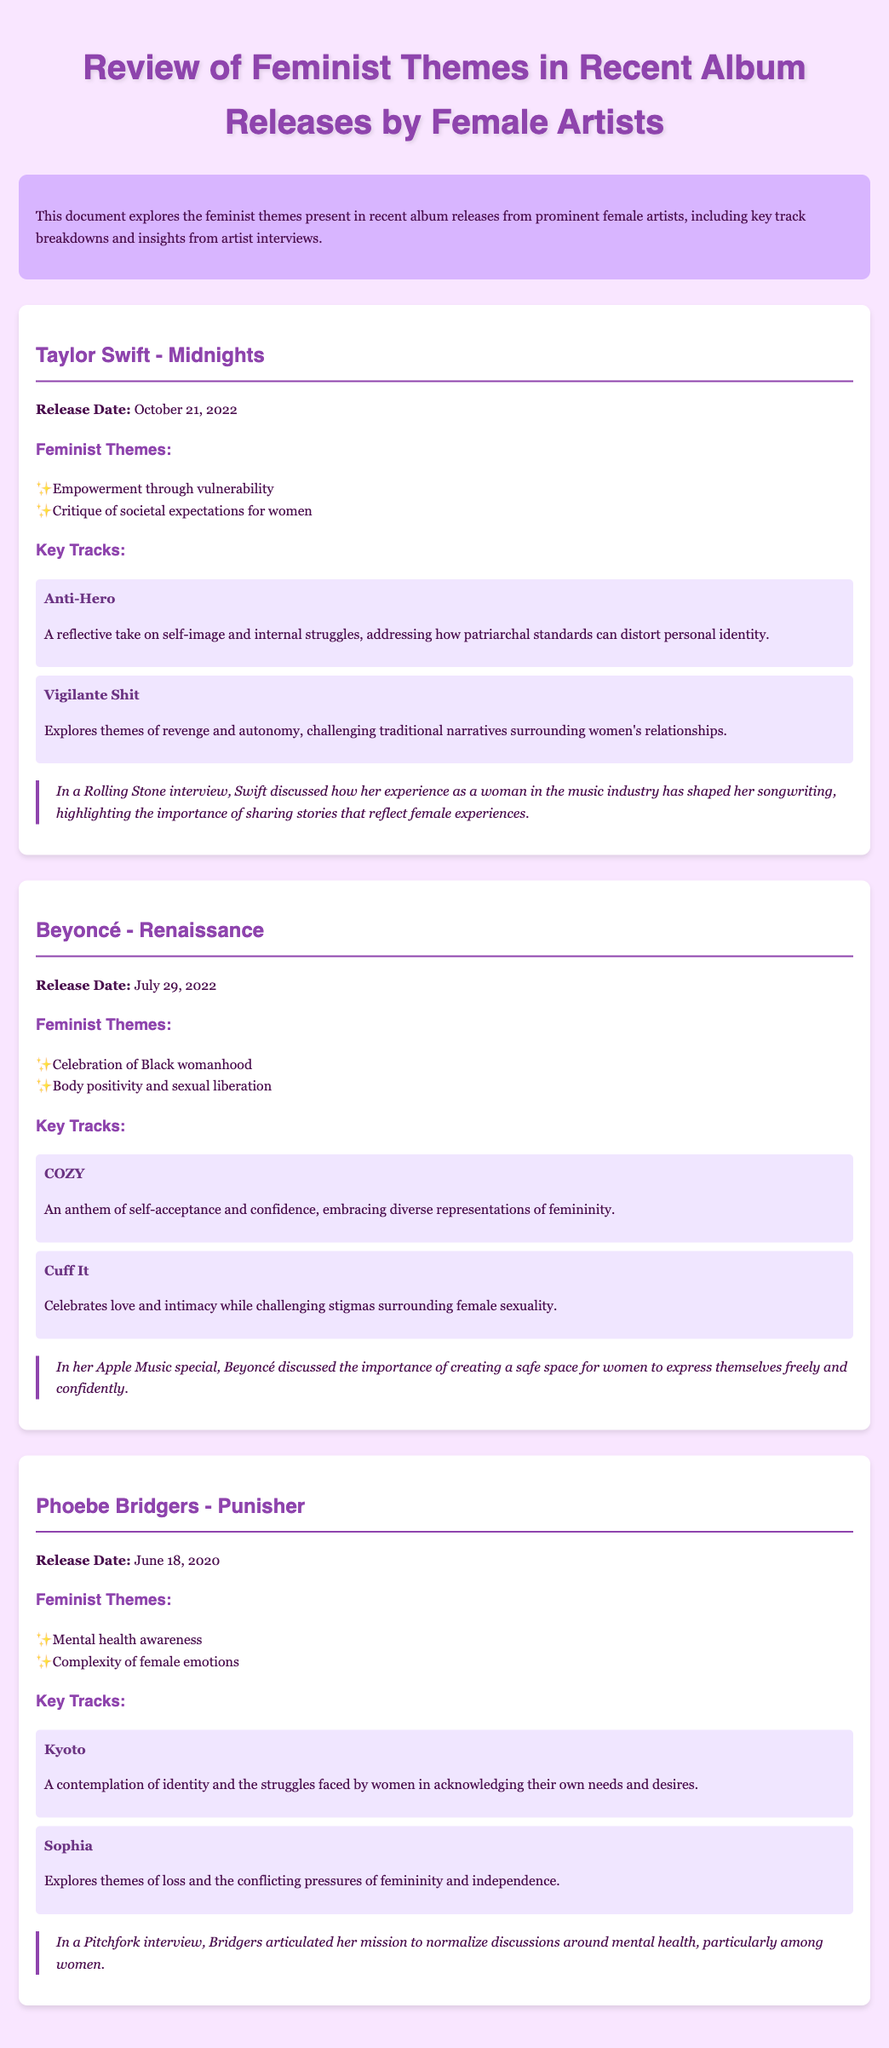What is the title of Taylor Swift's album? The title of Taylor Swift's album is "Midnights."
Answer: Midnights When was Beyoncé's album "Renaissance" released? The document states the release date of Beyoncé's album "Renaissance" as July 29, 2022.
Answer: July 29, 2022 What feminist theme is associated with Phoebe Bridgers' "Punisher"? The document mentions that one of the feminist themes in "Punisher" is mental health awareness.
Answer: Mental health awareness Which track from "Midnights" addresses self-image and internal struggles? The track "Anti-Hero" is highlighted in the document as addressing self-image and internal struggles.
Answer: Anti-Hero What key track from "Renaissance" celebrates body positivity? The track "Cuff It" is noted in the document as celebrating body positivity and sexual liberation.
Answer: Cuff It How does Taylor Swift describe her experience in the music industry in the interview? In the interview, Taylor Swift discusses the importance of sharing stories that reflect female experiences as shaped by her experience in the music industry.
Answer: Sharing stories that reflect female experiences How does Phoebe Bridgers aim to impact discussions around mental health? The document indicates that Phoebe Bridgers aims to normalize discussions around mental health, particularly among women.
Answer: Normalize discussions around mental health What does Beyoncé emphasize in her Apple Music special? Beyoncé discusses the importance of creating a safe space for women to express themselves freely and confidently in her Apple Music special.
Answer: Creating a safe space for women Name a theme critiqued by Taylor Swift in her album. Taylor Swift critiques societal expectations for women in her album "Midnights."
Answer: Critique of societal expectations for women 